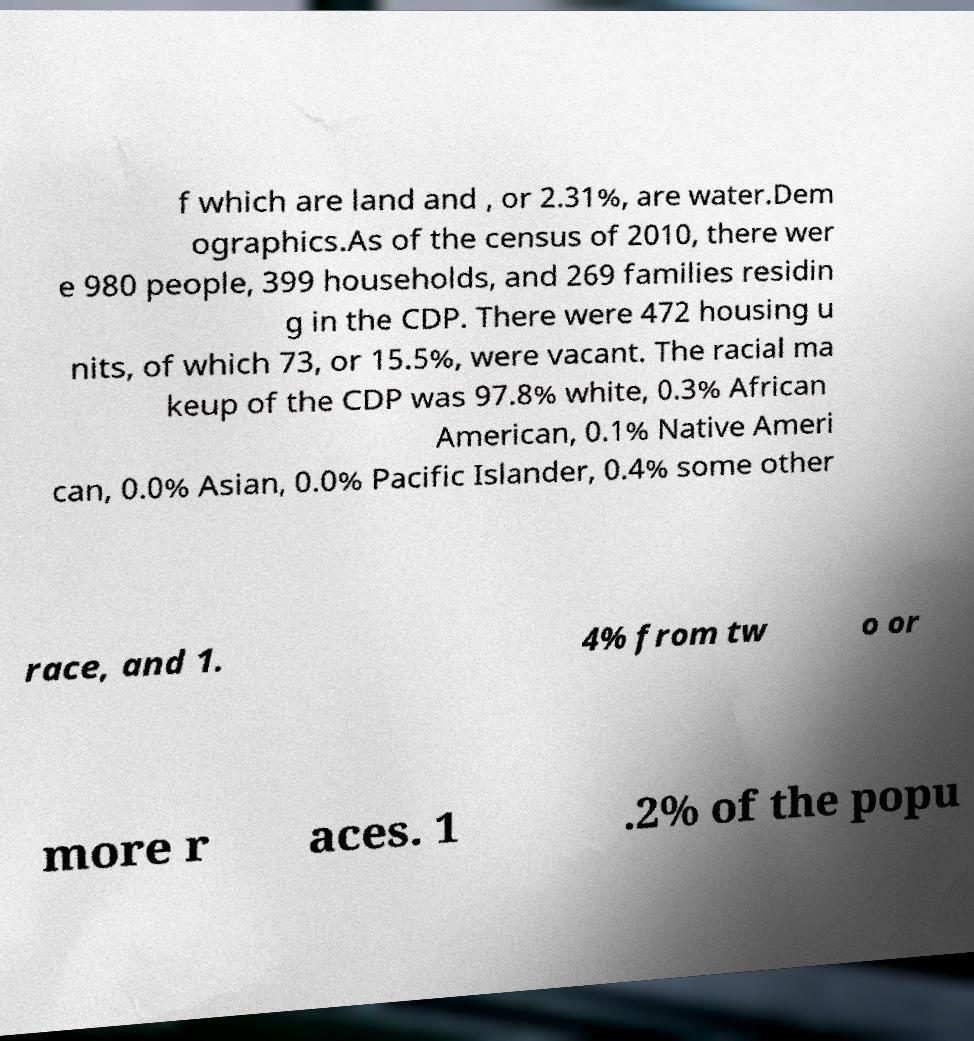There's text embedded in this image that I need extracted. Can you transcribe it verbatim? f which are land and , or 2.31%, are water.Dem ographics.As of the census of 2010, there wer e 980 people, 399 households, and 269 families residin g in the CDP. There were 472 housing u nits, of which 73, or 15.5%, were vacant. The racial ma keup of the CDP was 97.8% white, 0.3% African American, 0.1% Native Ameri can, 0.0% Asian, 0.0% Pacific Islander, 0.4% some other race, and 1. 4% from tw o or more r aces. 1 .2% of the popu 